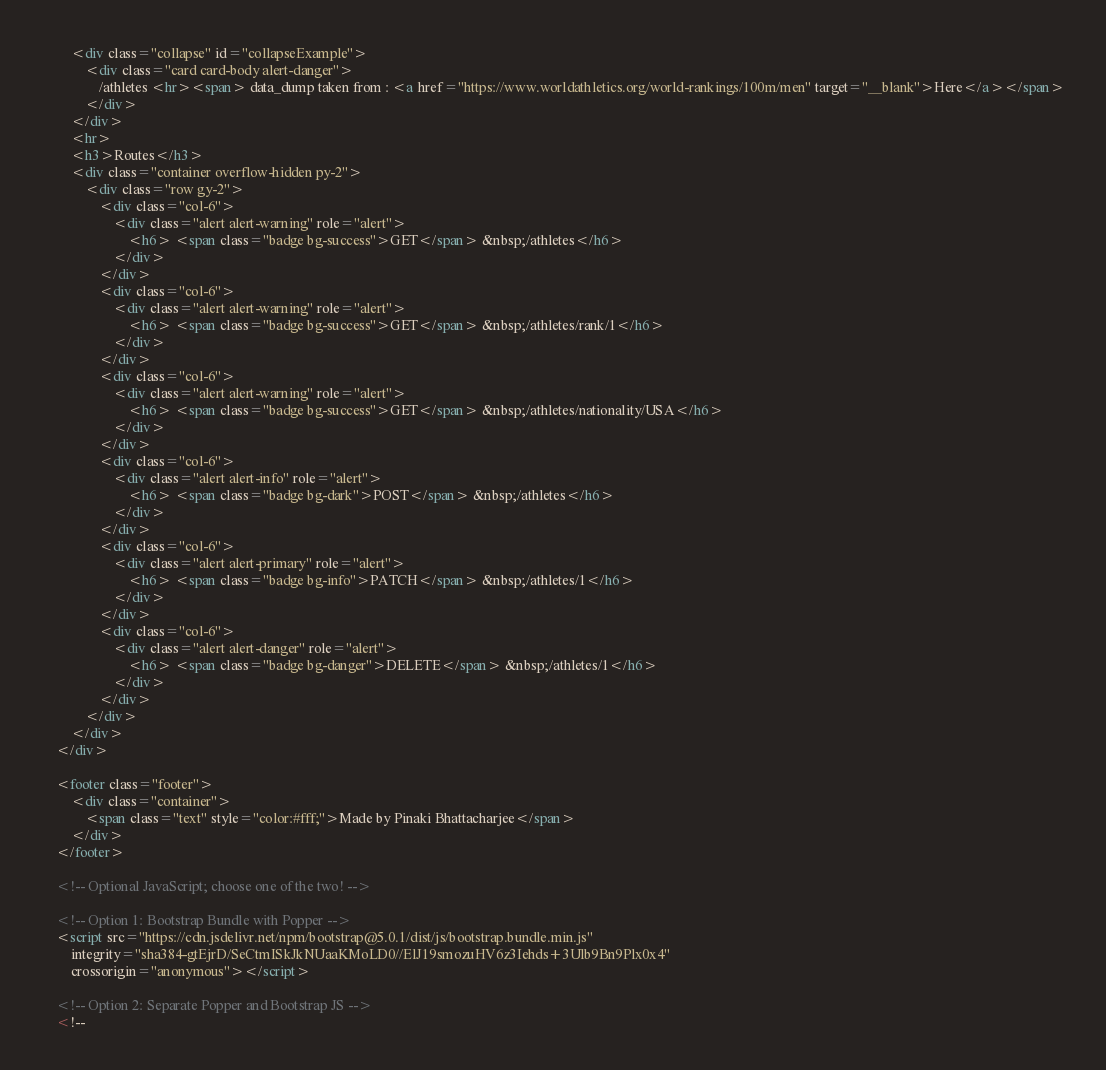<code> <loc_0><loc_0><loc_500><loc_500><_HTML_>        <div class="collapse" id="collapseExample">
            <div class="card card-body alert-danger">
                /athletes <hr><span> data_dump taken from : <a href="https://www.worldathletics.org/world-rankings/100m/men" target="__blank">Here</a></span>
            </div>
        </div>
        <hr>
        <h3>Routes</h3>
        <div class="container overflow-hidden py-2">
            <div class="row gy-2">
                <div class="col-6">
                    <div class="alert alert-warning" role="alert">
                        <h6> <span class="badge bg-success">GET</span> &nbsp;/athletes</h6>
                    </div>
                </div>
                <div class="col-6">
                    <div class="alert alert-warning" role="alert">
                        <h6> <span class="badge bg-success">GET</span> &nbsp;/athletes/rank/1</h6>
                    </div>
                </div>
                <div class="col-6">
                    <div class="alert alert-warning" role="alert">
                        <h6> <span class="badge bg-success">GET</span> &nbsp;/athletes/nationality/USA</h6>
                    </div>
                </div>
                <div class="col-6">
                    <div class="alert alert-info" role="alert">
                        <h6> <span class="badge bg-dark">POST</span> &nbsp;/athletes</h6>
                    </div>
                </div>
                <div class="col-6">
                    <div class="alert alert-primary" role="alert">
                        <h6> <span class="badge bg-info">PATCH</span> &nbsp;/athletes/1</h6>
                    </div>
                </div>
                <div class="col-6">
                    <div class="alert alert-danger" role="alert">
                        <h6> <span class="badge bg-danger">DELETE</span> &nbsp;/athletes/1</h6>
                    </div>
                </div>
            </div>
        </div>
    </div>

    <footer class="footer">
        <div class="container">
            <span class="text" style="color:#fff;">Made by Pinaki Bhattacharjee</span>
        </div>
    </footer>

    <!-- Optional JavaScript; choose one of the two! -->

    <!-- Option 1: Bootstrap Bundle with Popper -->
    <script src="https://cdn.jsdelivr.net/npm/bootstrap@5.0.1/dist/js/bootstrap.bundle.min.js"
        integrity="sha384-gtEjrD/SeCtmISkJkNUaaKMoLD0//ElJ19smozuHV6z3Iehds+3Ulb9Bn9Plx0x4"
        crossorigin="anonymous"></script>

    <!-- Option 2: Separate Popper and Bootstrap JS -->
    <!--</code> 